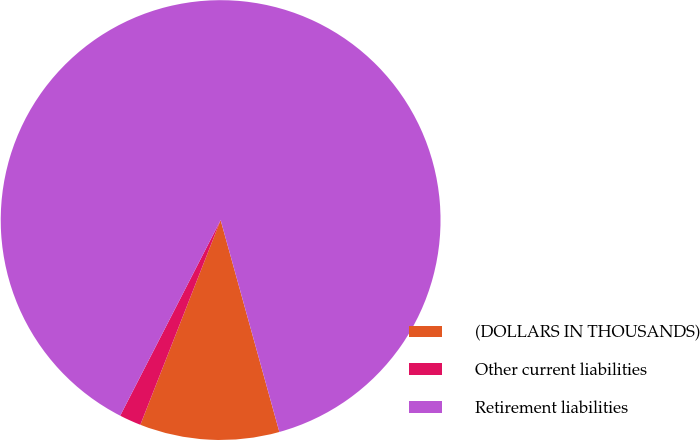Convert chart to OTSL. <chart><loc_0><loc_0><loc_500><loc_500><pie_chart><fcel>(DOLLARS IN THOUSANDS)<fcel>Other current liabilities<fcel>Retirement liabilities<nl><fcel>10.25%<fcel>1.6%<fcel>88.14%<nl></chart> 